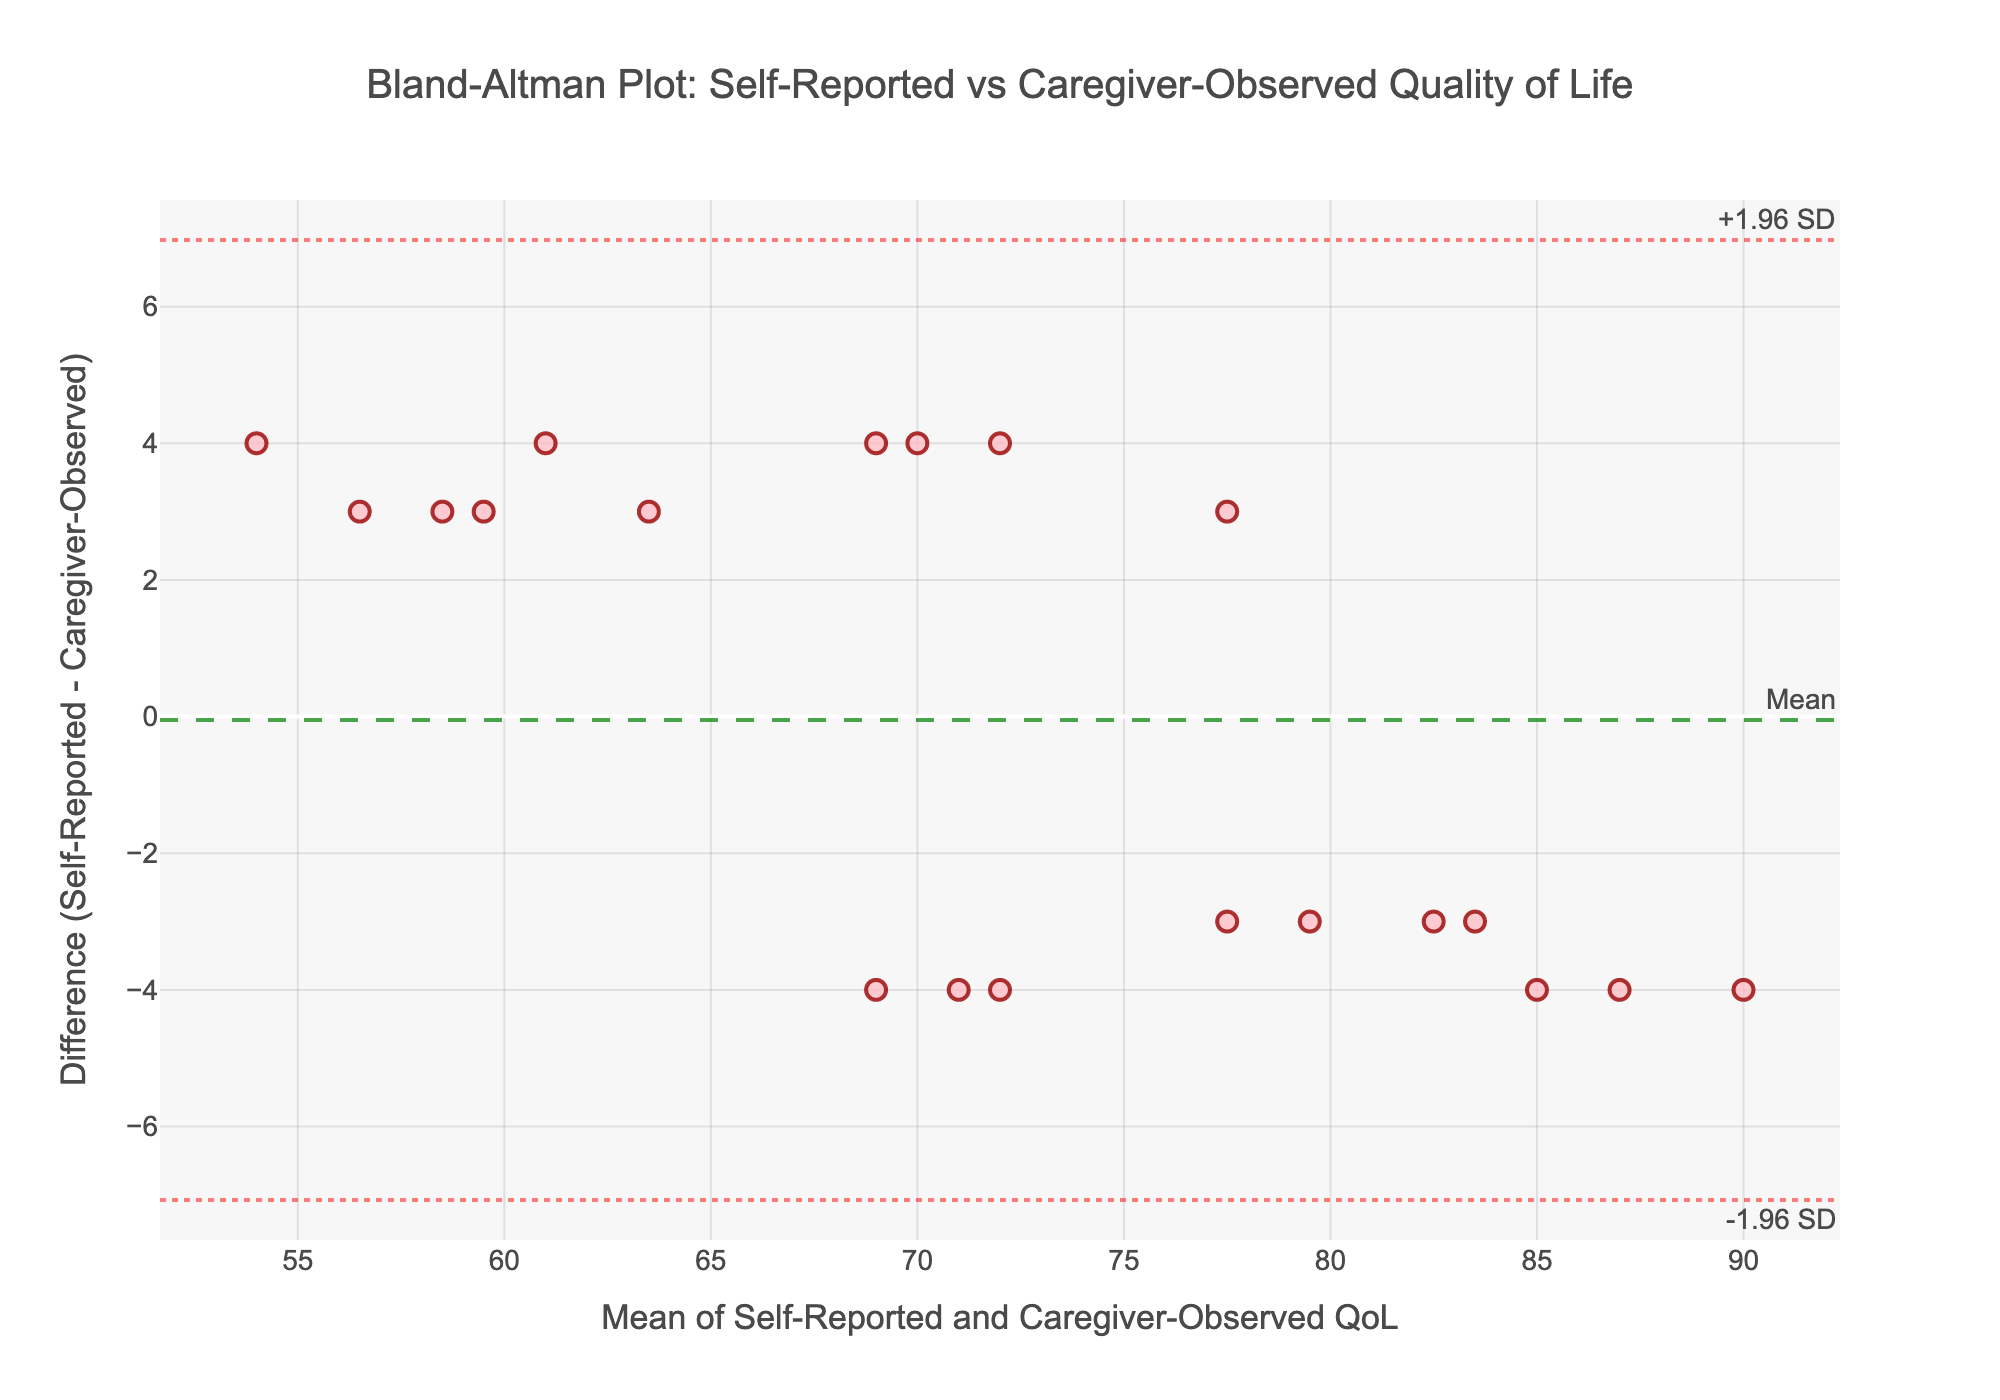What's the title of the figure? The title is usually positioned at the top of the figure, making it one of the most obvious elements to identify.
Answer: Bland-Altman Plot: Self-Reported vs Caregiver-Observed Quality of Life How many data points are plotted on the graph? Each patient has one corresponding point on the plot. Counting the number of entries, we can determine the number of data points.
Answer: 20 What do the horizontal dashed and dotted lines represent in the plot? Horizontal dashed and dotted lines in Bland-Altman plots often denote the mean difference and limits of agreement. The dashed line represents the mean difference, while the dotted lines represent the +1.96 SD and -1.96 SD limits.
Answer: Mean, +1.96 SD, -1.96 SD What is the approximate mean difference between self-reported and caregiver-observed QoL scores? The mean difference is indicated by the horizontal dashed line, typically accompanied by an annotation for clarity.
Answer: ~-2 Based on the plot, which QoL score is generally higher: self-reported or caregiver-observed? To determine this, observe the position of most points relative to the y=0 line. If most points lie below this line, it indicates that self-reported scores are generally higher as the difference (self-reported - caregiver-observed) is positive.
Answer: Self-reported What is the range of the mean values (mean of Self-Reported and Caregiver-Observed QoL) on the x-axis? The x-axis range can be determined by observing the minimum and maximum values on the axis.
Answer: 55 to 90 Which point in the plot represents the largest positive difference between self-reported and caregiver-observed QoL scores? Identify the point with the highest y-value, as it represents the largest positive difference.
Answer: Daniel Taylor (mean value is highest and has a positive difference) Are there any outliers, and if so, what might they indicate? Outliers can be identified as points that fall significantly outside the limits of agreement. These indicate substantial discrepancies between self-reported and caregiver-observed scores.
Answer: No significant outliers What is the approximate value of the upper limit of agreement (+1.96 SD)? The upper limit of agreement is indicated by the upper horizontal dotted line, often with an accompanying annotation.
Answer: ~6 How does the variation in differences between self-reported and caregiver-observed scores relate to the mean scores? In a Bland-Altman plot, we assess the spread of differences along the x-axis. If the spread increases or decreases systematically, it indicates a relationship between measurement error and the actual measurement size.
Answer: No clear pattern, differences are uniformly spread 